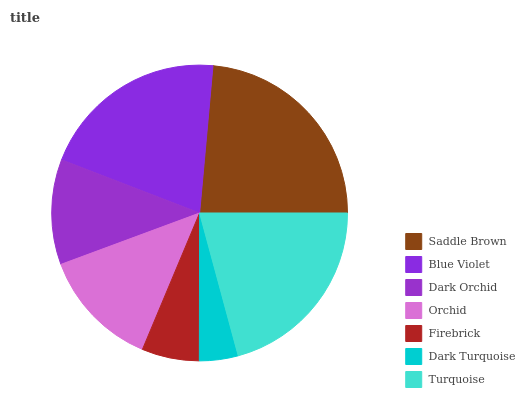Is Dark Turquoise the minimum?
Answer yes or no. Yes. Is Saddle Brown the maximum?
Answer yes or no. Yes. Is Blue Violet the minimum?
Answer yes or no. No. Is Blue Violet the maximum?
Answer yes or no. No. Is Saddle Brown greater than Blue Violet?
Answer yes or no. Yes. Is Blue Violet less than Saddle Brown?
Answer yes or no. Yes. Is Blue Violet greater than Saddle Brown?
Answer yes or no. No. Is Saddle Brown less than Blue Violet?
Answer yes or no. No. Is Orchid the high median?
Answer yes or no. Yes. Is Orchid the low median?
Answer yes or no. Yes. Is Turquoise the high median?
Answer yes or no. No. Is Blue Violet the low median?
Answer yes or no. No. 